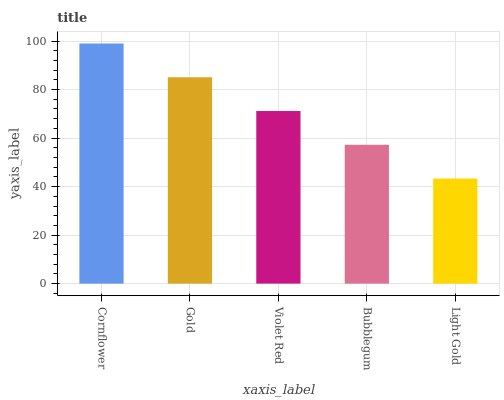Is Light Gold the minimum?
Answer yes or no. Yes. Is Cornflower the maximum?
Answer yes or no. Yes. Is Gold the minimum?
Answer yes or no. No. Is Gold the maximum?
Answer yes or no. No. Is Cornflower greater than Gold?
Answer yes or no. Yes. Is Gold less than Cornflower?
Answer yes or no. Yes. Is Gold greater than Cornflower?
Answer yes or no. No. Is Cornflower less than Gold?
Answer yes or no. No. Is Violet Red the high median?
Answer yes or no. Yes. Is Violet Red the low median?
Answer yes or no. Yes. Is Gold the high median?
Answer yes or no. No. Is Light Gold the low median?
Answer yes or no. No. 